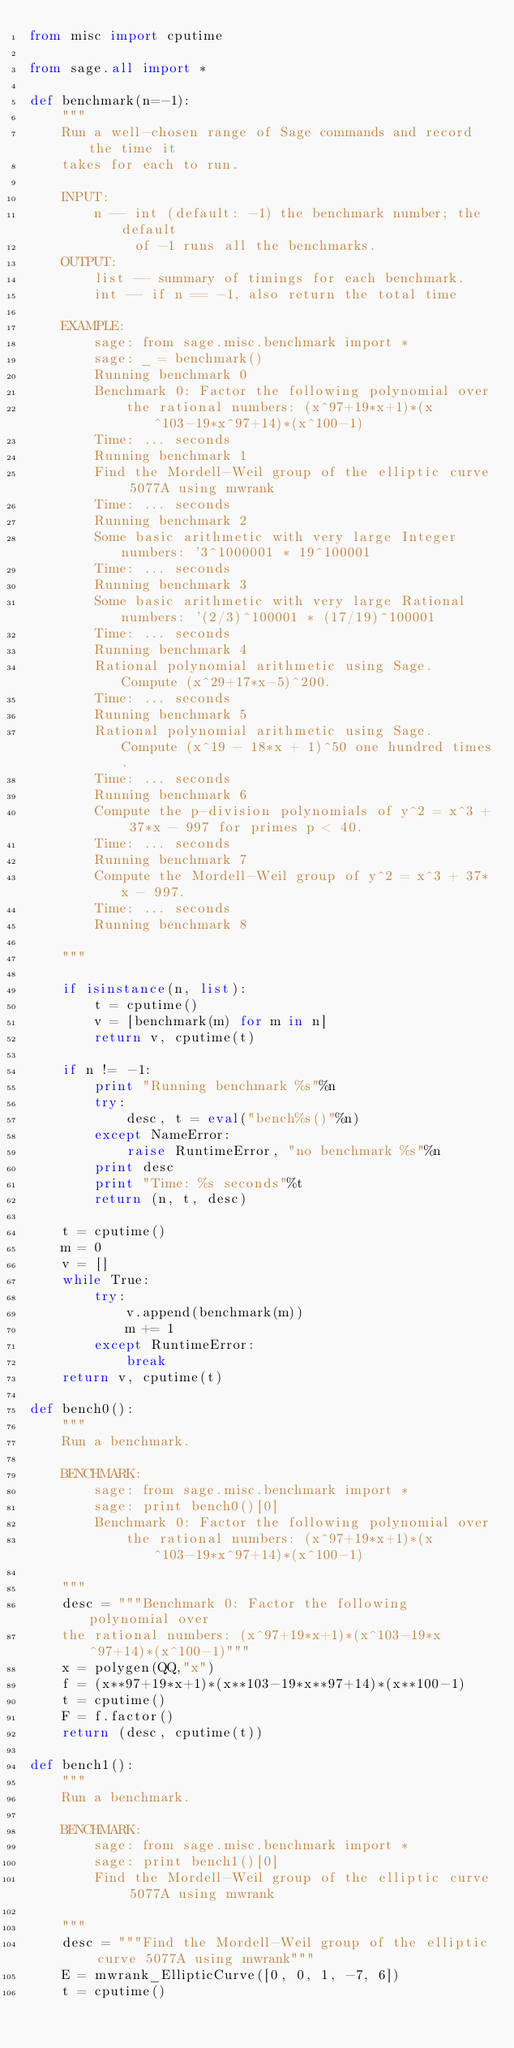Convert code to text. <code><loc_0><loc_0><loc_500><loc_500><_Python_>from misc import cputime

from sage.all import *

def benchmark(n=-1):
    """
    Run a well-chosen range of Sage commands and record the time it
    takes for each to run.

    INPUT:
        n -- int (default: -1) the benchmark number; the default
             of -1 runs all the benchmarks.
    OUTPUT:
        list -- summary of timings for each benchmark.
        int -- if n == -1, also return the total time

    EXAMPLE:
        sage: from sage.misc.benchmark import *
        sage: _ = benchmark()
        Running benchmark 0
        Benchmark 0: Factor the following polynomial over
            the rational numbers: (x^97+19*x+1)*(x^103-19*x^97+14)*(x^100-1)
        Time: ... seconds
        Running benchmark 1
        Find the Mordell-Weil group of the elliptic curve 5077A using mwrank
        Time: ... seconds
        Running benchmark 2
        Some basic arithmetic with very large Integer numbers: '3^1000001 * 19^100001
        Time: ... seconds
        Running benchmark 3
        Some basic arithmetic with very large Rational numbers: '(2/3)^100001 * (17/19)^100001
        Time: ... seconds
        Running benchmark 4
        Rational polynomial arithmetic using Sage. Compute (x^29+17*x-5)^200.
        Time: ... seconds
        Running benchmark 5
        Rational polynomial arithmetic using Sage. Compute (x^19 - 18*x + 1)^50 one hundred times.
        Time: ... seconds
        Running benchmark 6
        Compute the p-division polynomials of y^2 = x^3 + 37*x - 997 for primes p < 40.
        Time: ... seconds
        Running benchmark 7
        Compute the Mordell-Weil group of y^2 = x^3 + 37*x - 997.
        Time: ... seconds
        Running benchmark 8

    """

    if isinstance(n, list):
        t = cputime()
        v = [benchmark(m) for m in n]
        return v, cputime(t)

    if n != -1:
        print "Running benchmark %s"%n
        try:
            desc, t = eval("bench%s()"%n)
        except NameError:
            raise RuntimeError, "no benchmark %s"%n
        print desc
        print "Time: %s seconds"%t
        return (n, t, desc)

    t = cputime()
    m = 0
    v = []
    while True:
        try:
            v.append(benchmark(m))
            m += 1
        except RuntimeError:
            break
    return v, cputime(t)

def bench0():
    """
    Run a benchmark.

    BENCHMARK:
        sage: from sage.misc.benchmark import *
        sage: print bench0()[0]
        Benchmark 0: Factor the following polynomial over
            the rational numbers: (x^97+19*x+1)*(x^103-19*x^97+14)*(x^100-1)

    """
    desc = """Benchmark 0: Factor the following polynomial over
    the rational numbers: (x^97+19*x+1)*(x^103-19*x^97+14)*(x^100-1)"""
    x = polygen(QQ,"x")
    f = (x**97+19*x+1)*(x**103-19*x**97+14)*(x**100-1)
    t = cputime()
    F = f.factor()
    return (desc, cputime(t))

def bench1():
    """
    Run a benchmark.

    BENCHMARK:
        sage: from sage.misc.benchmark import *
        sage: print bench1()[0]
        Find the Mordell-Weil group of the elliptic curve 5077A using mwrank

    """
    desc = """Find the Mordell-Weil group of the elliptic curve 5077A using mwrank"""
    E = mwrank_EllipticCurve([0, 0, 1, -7, 6])
    t = cputime()</code> 